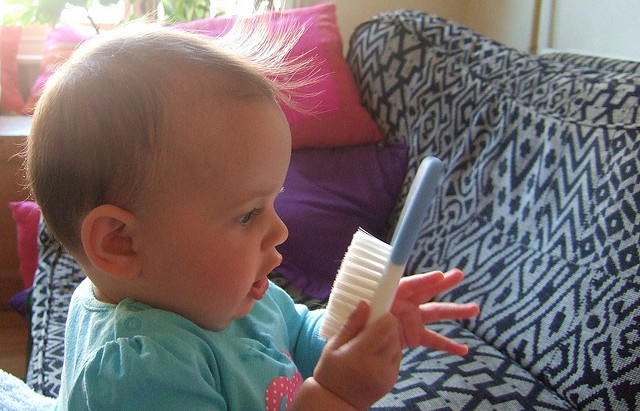Describe the objects in this image and their specific colors. I can see people in white, brown, gray, and maroon tones and couch in white, gray, darkgray, and black tones in this image. 